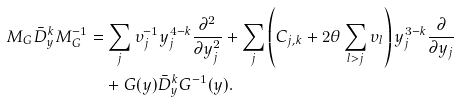<formula> <loc_0><loc_0><loc_500><loc_500>M _ { G } \bar { D } ^ { k } _ { y } M ^ { - 1 } _ { G } & = \sum _ { j } \upsilon _ { j } ^ { - 1 } y _ { j } ^ { 4 - k } \frac { \partial ^ { 2 } } { \partial y _ { j } ^ { 2 } } + \sum _ { j } \left ( C _ { j , k } + 2 \theta \sum _ { l > j } \upsilon _ { l } \right ) y _ { j } ^ { 3 - k } \frac { \partial } { \partial y _ { j } } \\ & \quad + G ( y ) \bar { D } ^ { k } _ { y } G ^ { - 1 } ( y ) .</formula> 